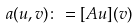Convert formula to latex. <formula><loc_0><loc_0><loc_500><loc_500>a ( u , v ) \colon = [ A u ] ( v )</formula> 